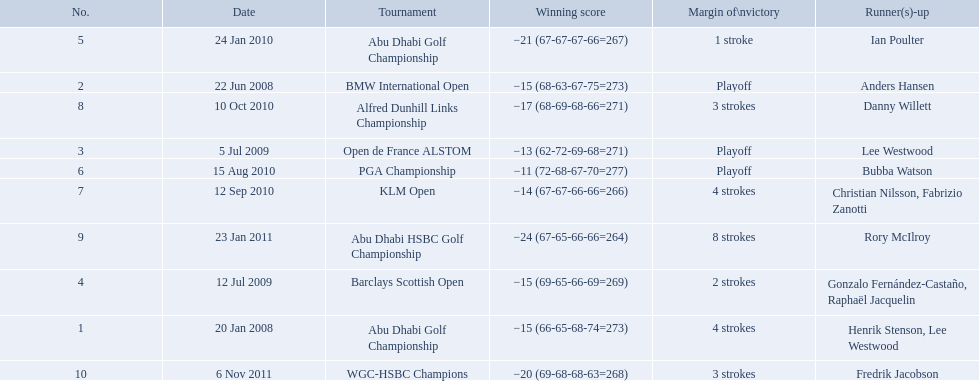What are all of the tournaments? Abu Dhabi Golf Championship, BMW International Open, Open de France ALSTOM, Barclays Scottish Open, Abu Dhabi Golf Championship, PGA Championship, KLM Open, Alfred Dunhill Links Championship, Abu Dhabi HSBC Golf Championship, WGC-HSBC Champions. What was the score during each? −15 (66-65-68-74=273), −15 (68-63-67-75=273), −13 (62-72-69-68=271), −15 (69-65-66-69=269), −21 (67-67-67-66=267), −11 (72-68-67-70=277), −14 (67-67-66-66=266), −17 (68-69-68-66=271), −24 (67-65-66-66=264), −20 (69-68-68-63=268). And who was the runner-up in each? Henrik Stenson, Lee Westwood, Anders Hansen, Lee Westwood, Gonzalo Fernández-Castaño, Raphaël Jacquelin, Ian Poulter, Bubba Watson, Christian Nilsson, Fabrizio Zanotti, Danny Willett, Rory McIlroy, Fredrik Jacobson. What about just during pga games? Bubba Watson. How many strokes were in the klm open by martin kaymer? 4 strokes. How many strokes were in the abu dhabi golf championship? 4 strokes. Could you parse the entire table as a dict? {'header': ['No.', 'Date', 'Tournament', 'Winning score', 'Margin of\\nvictory', 'Runner(s)-up'], 'rows': [['5', '24 Jan 2010', 'Abu Dhabi Golf Championship', '−21 (67-67-67-66=267)', '1 stroke', 'Ian Poulter'], ['2', '22 Jun 2008', 'BMW International Open', '−15 (68-63-67-75=273)', 'Playoff', 'Anders Hansen'], ['8', '10 Oct 2010', 'Alfred Dunhill Links Championship', '−17 (68-69-68-66=271)', '3 strokes', 'Danny Willett'], ['3', '5 Jul 2009', 'Open de France ALSTOM', '−13 (62-72-69-68=271)', 'Playoff', 'Lee Westwood'], ['6', '15 Aug 2010', 'PGA Championship', '−11 (72-68-67-70=277)', 'Playoff', 'Bubba Watson'], ['7', '12 Sep 2010', 'KLM Open', '−14 (67-67-66-66=266)', '4 strokes', 'Christian Nilsson, Fabrizio Zanotti'], ['9', '23 Jan 2011', 'Abu Dhabi HSBC Golf Championship', '−24 (67-65-66-66=264)', '8 strokes', 'Rory McIlroy'], ['4', '12 Jul 2009', 'Barclays Scottish Open', '−15 (69-65-66-69=269)', '2 strokes', 'Gonzalo Fernández-Castaño, Raphaël Jacquelin'], ['1', '20 Jan 2008', 'Abu Dhabi Golf Championship', '−15 (66-65-68-74=273)', '4 strokes', 'Henrik Stenson, Lee Westwood'], ['10', '6 Nov 2011', 'WGC-HSBC Champions', '−20 (69-68-68-63=268)', '3 strokes', 'Fredrik Jacobson']]} How many more strokes were there in the klm than the barclays open? 2 strokes. 